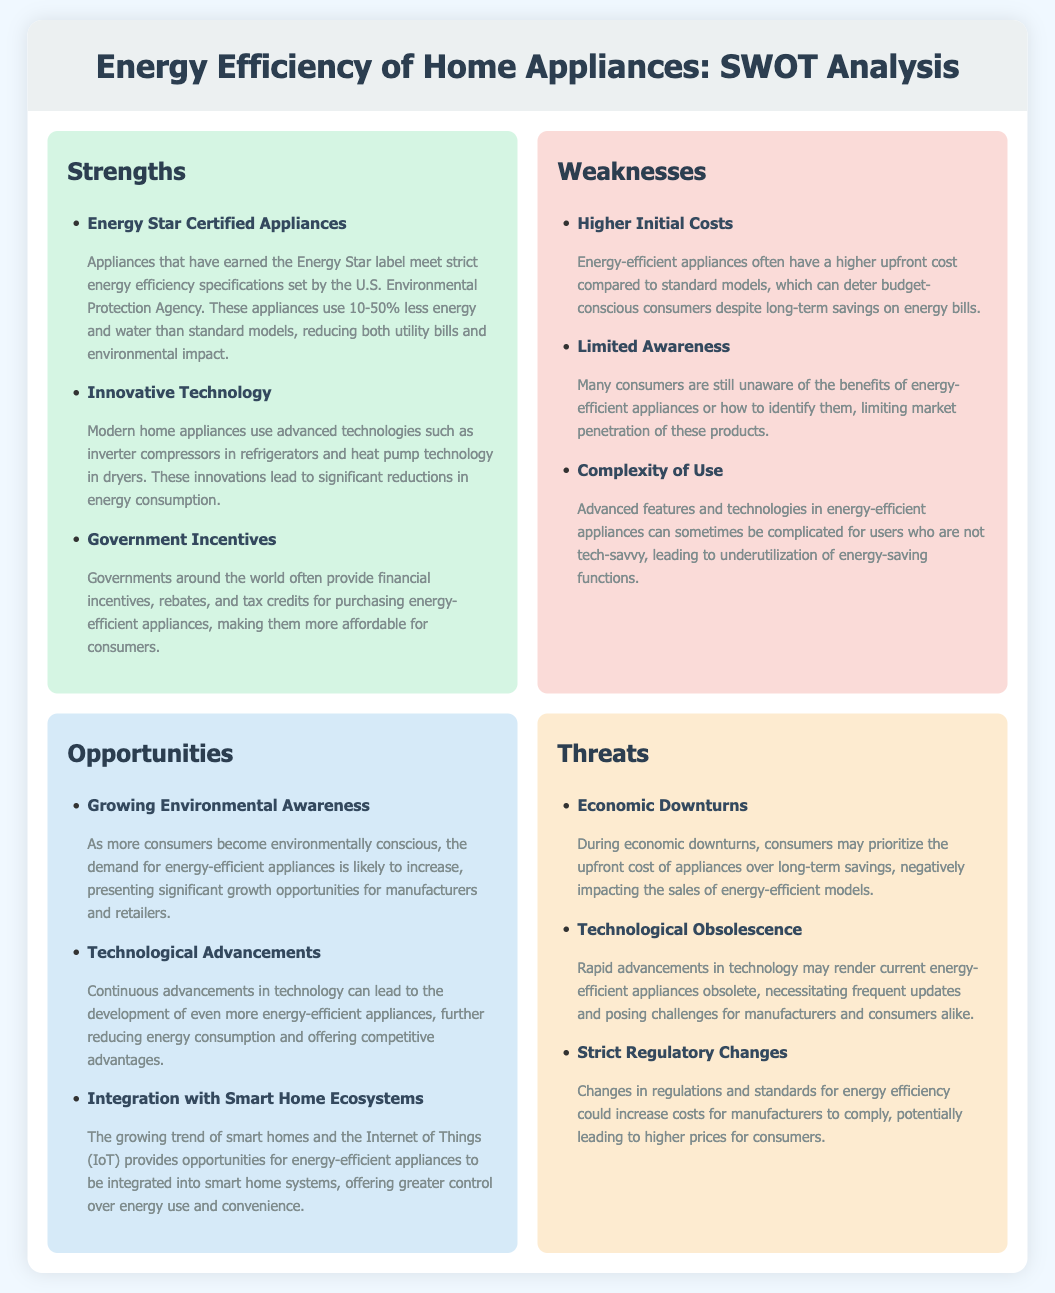What is the Energy Star label? The Energy Star label indicates appliances that meet strict energy efficiency specifications set by the U.S. Environmental Protection Agency.
Answer: Energy Star label What is one innovative technology used in modern home appliances? The document mentions inverter compressors in refrigerators and heat pump technology in dryers as examples of innovative technology.
Answer: Inverter compressors What are government incentives for energy-efficient appliances? Governments often provide financial incentives, rebates, and tax credits to encourage the purchase of energy-efficient appliances.
Answer: Financial incentives What is a common weakness of energy-efficient appliances concerning costs? Energy-efficient appliances often have a higher upfront cost compared to standard models.
Answer: Higher Initial Costs What opportunity is associated with increasing consumer consciousness? Growing environmental awareness among consumers is expected to increase demand for energy-efficient appliances.
Answer: Growing Environmental Awareness What can hinder market penetration of energy-efficient appliances? Limited awareness among consumers about the benefits and identification of energy-efficient appliances can hinder market growth.
Answer: Limited Awareness What threat relates to consumers’ priorities during economic downturns? Economic downturns may lead consumers to prioritize the upfront cost of appliances over long-term savings.
Answer: Economic Downturns What advanced capability is highlighted in the opportunities section? The integration of energy-efficient appliances with smart home systems is highlighted as a significant opportunity.
Answer: Integration with Smart Home Ecosystems What is one potential threat posed by rapid technological advancements? Technological obsolescence may render current energy-efficient appliances obsolete quickly, presenting challenges.
Answer: Technological Obsolescence 